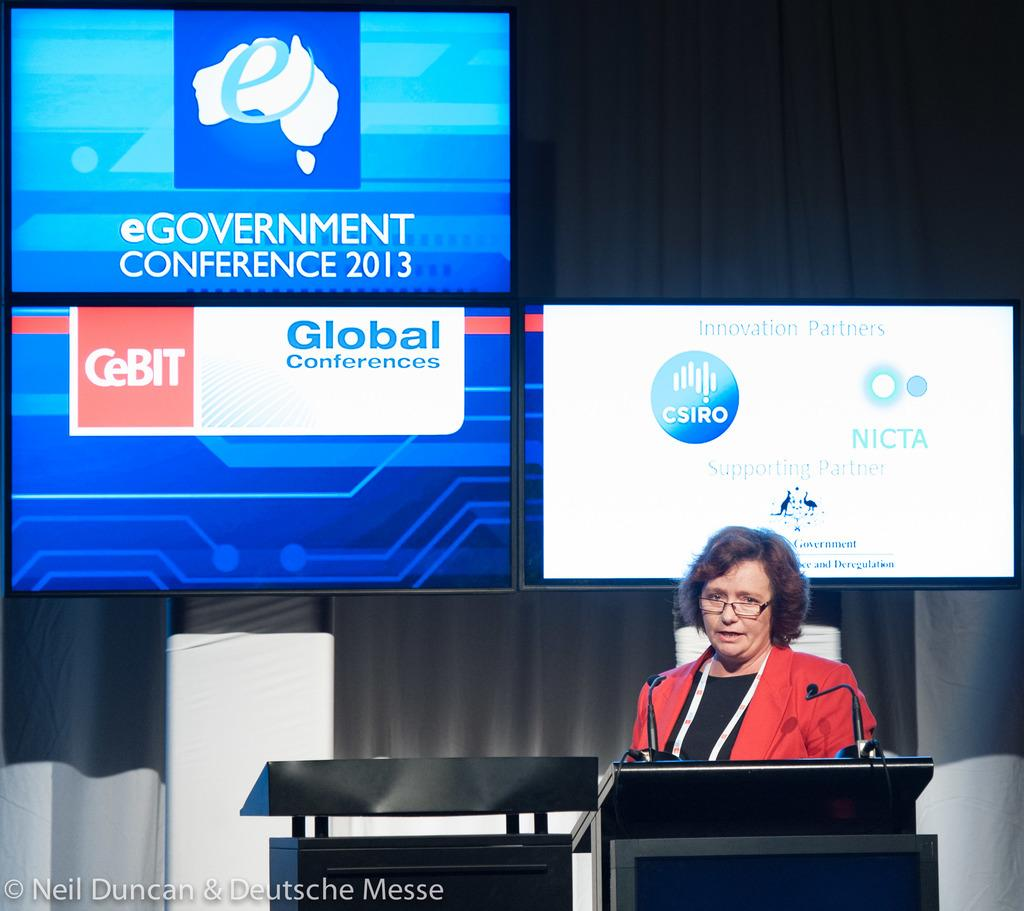Provide a one-sentence caption for the provided image. A woman in glasses gives a speech at the eGovernment Conference 2013. 